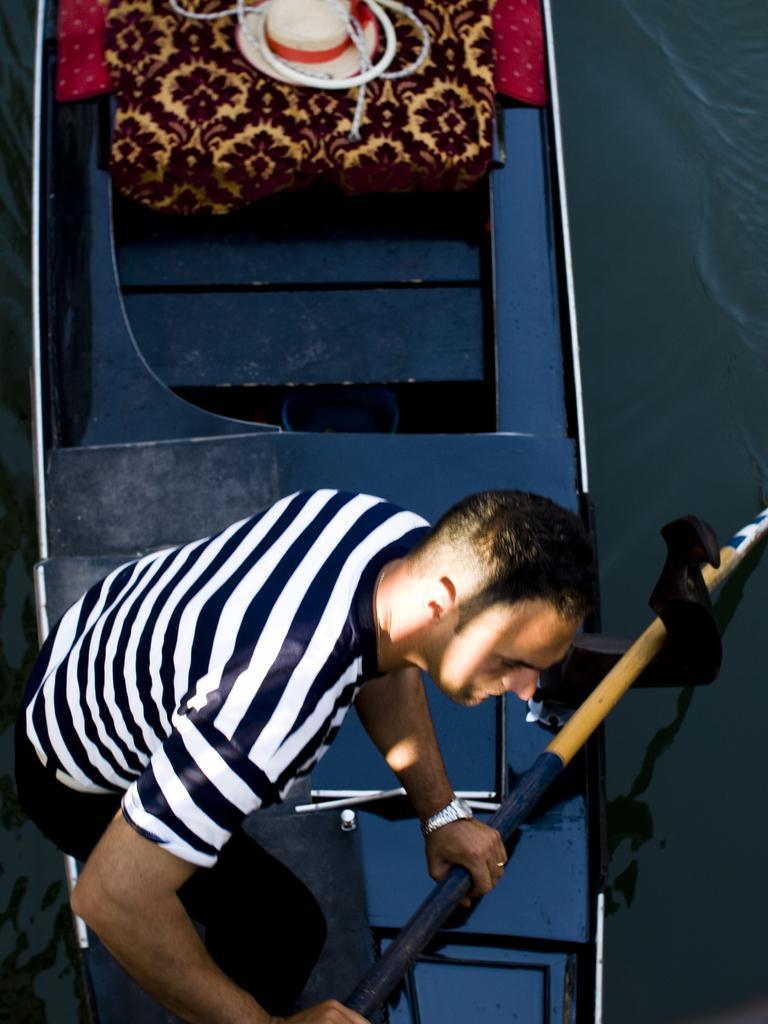Can you describe this image briefly? In the image in the center, we can see one person standing and holding some object. In the background there is a wall, bag, hat, cloth and a few other objects. 